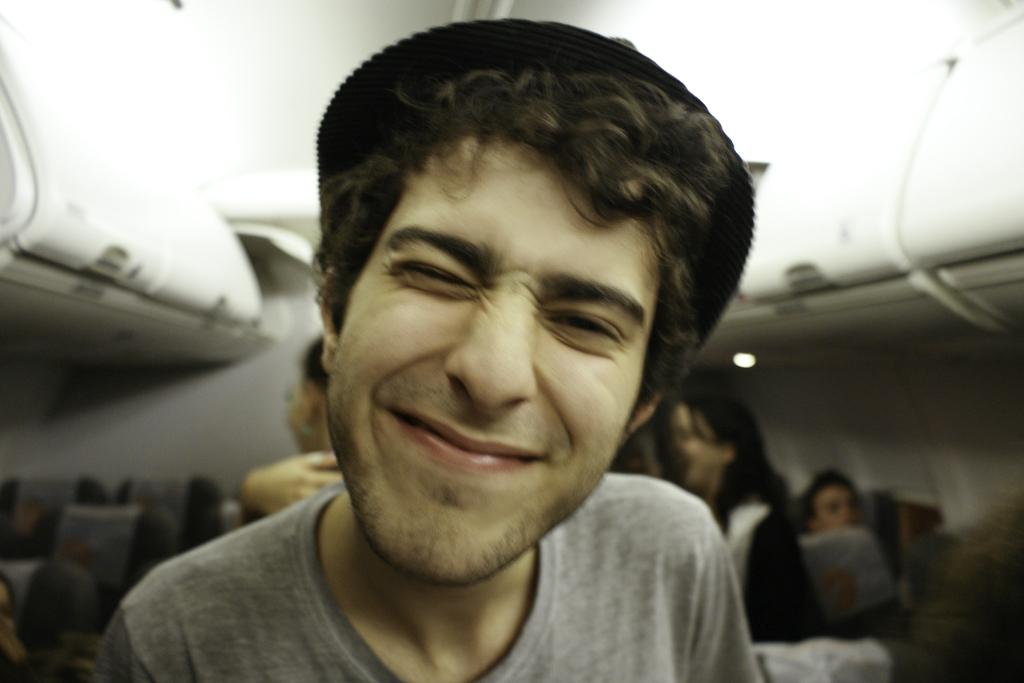Who is present in the image? There is a man in the image. What is the man wearing on his head? The man is wearing a cap. What type of clothing is the man wearing on his upper body? The man is wearing a t-shirt. What type of animals can be seen at the zoo in the image? There is no zoo or animals present in the image; it features a man wearing a cap and a t-shirt. How can the man be helped in the image? There is no indication in the image that the man needs help, and no information is provided about how to help him. 